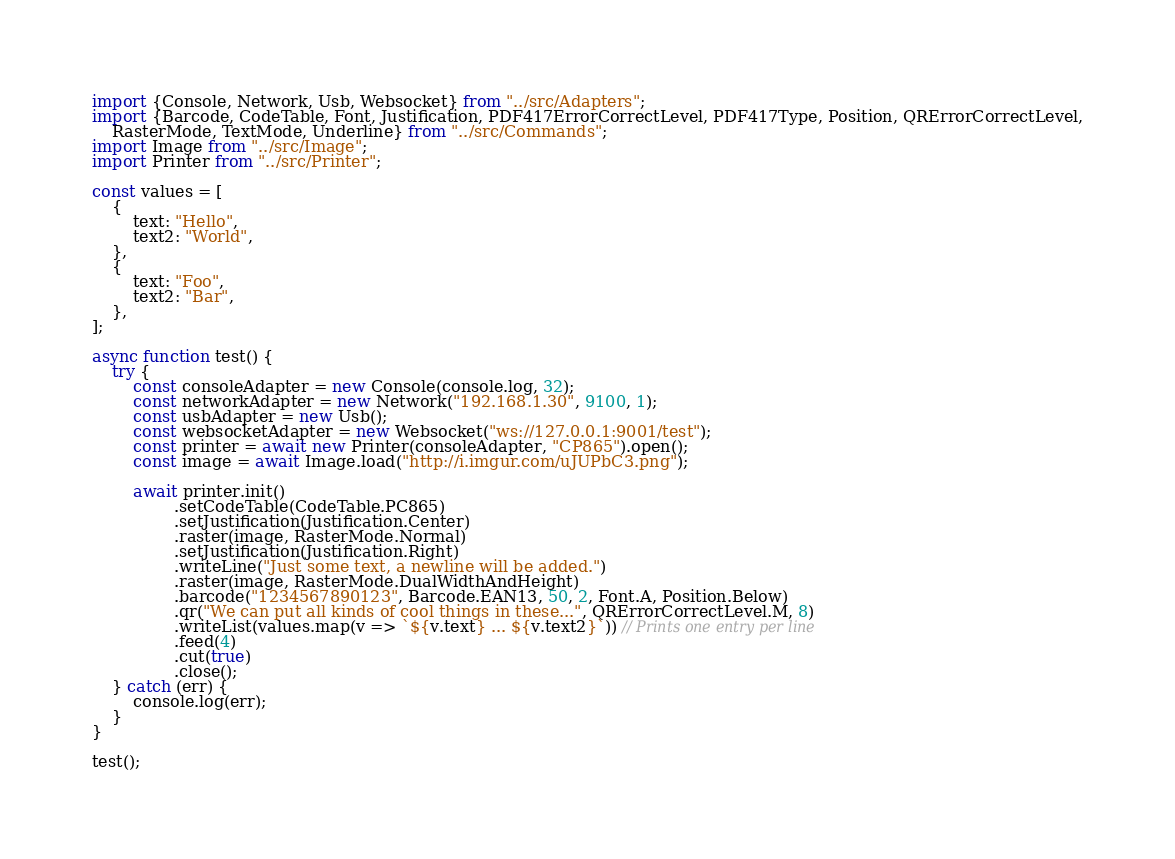<code> <loc_0><loc_0><loc_500><loc_500><_TypeScript_>import {Console, Network, Usb, Websocket} from "../src/Adapters";
import {Barcode, CodeTable, Font, Justification, PDF417ErrorCorrectLevel, PDF417Type, Position, QRErrorCorrectLevel,
    RasterMode, TextMode, Underline} from "../src/Commands";
import Image from "../src/Image";
import Printer from "../src/Printer";

const values = [
    {
        text: "Hello",
        text2: "World",
    },
    {
        text: "Foo",
        text2: "Bar",
    },
];

async function test() {
    try {
        const consoleAdapter = new Console(console.log, 32);
        const networkAdapter = new Network("192.168.1.30", 9100, 1);
        const usbAdapter = new Usb();
        const websocketAdapter = new Websocket("ws://127.0.0.1:9001/test");
        const printer = await new Printer(consoleAdapter, "CP865").open();
        const image = await Image.load("http://i.imgur.com/uJUPbC3.png");

        await printer.init()
                .setCodeTable(CodeTable.PC865)
                .setJustification(Justification.Center)
                .raster(image, RasterMode.Normal)
                .setJustification(Justification.Right)
                .writeLine("Just some text, a newline will be added.")
                .raster(image, RasterMode.DualWidthAndHeight)
                .barcode("1234567890123", Barcode.EAN13, 50, 2, Font.A, Position.Below)
                .qr("We can put all kinds of cool things in these...", QRErrorCorrectLevel.M, 8)
                .writeList(values.map(v => `${v.text} ... ${v.text2}`)) // Prints one entry per line
                .feed(4)
                .cut(true)
                .close();
    } catch (err) {
        console.log(err);
    }
}

test();
</code> 